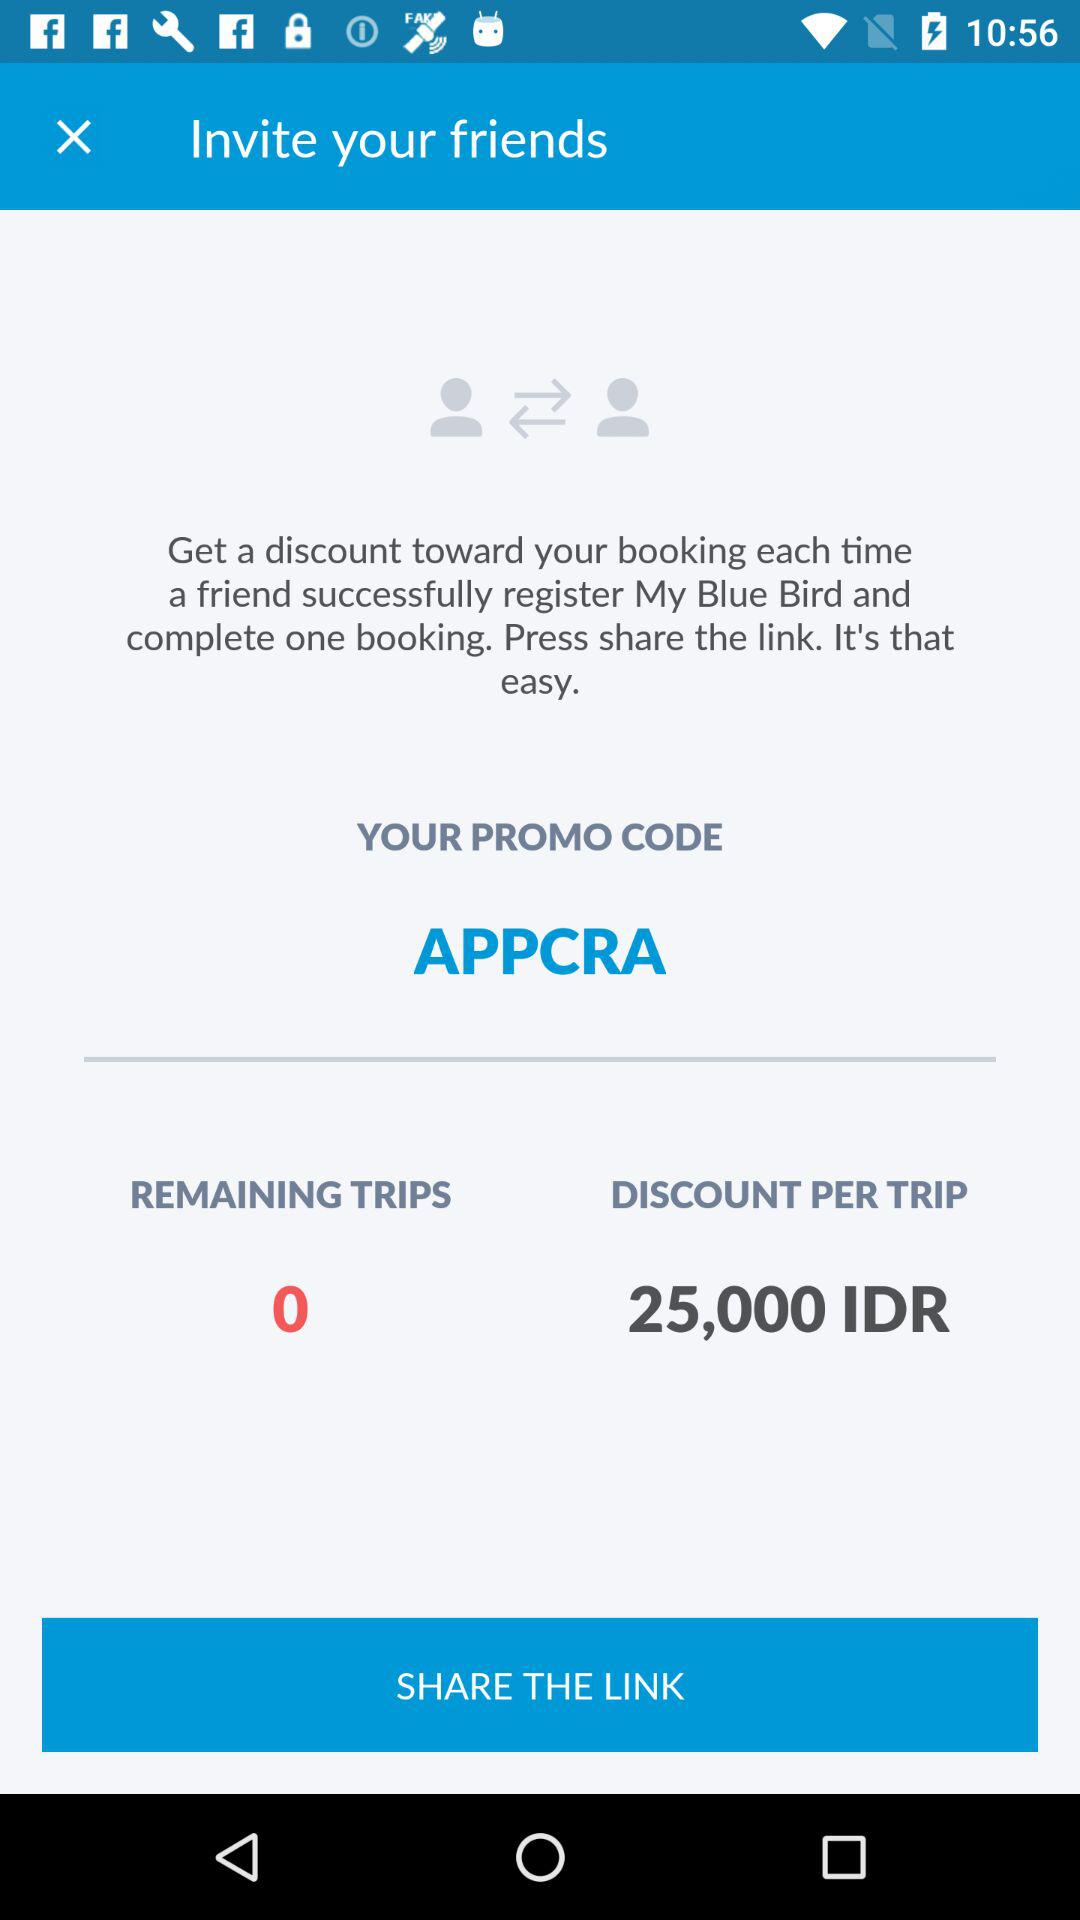How many remaining trips are there? There are 0 remaining trips. 